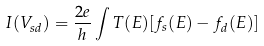Convert formula to latex. <formula><loc_0><loc_0><loc_500><loc_500>I ( V _ { s d } ) = \frac { 2 e } { h } \int { T ( E ) [ f _ { s } ( E ) - f _ { d } ( E ) ] }</formula> 